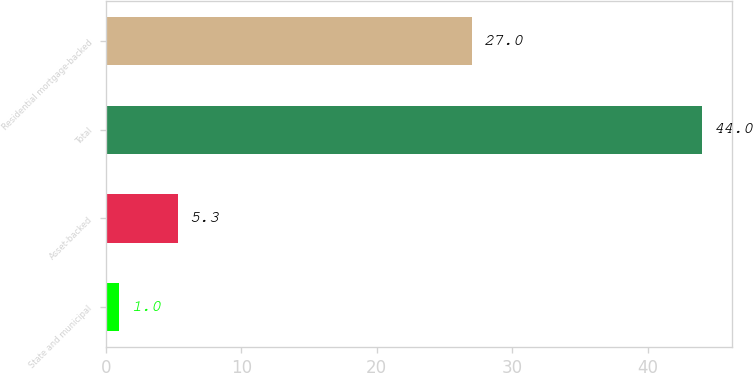Convert chart to OTSL. <chart><loc_0><loc_0><loc_500><loc_500><bar_chart><fcel>State and municipal<fcel>Asset-backed<fcel>Total<fcel>Residential mortgage-backed<nl><fcel>1<fcel>5.3<fcel>44<fcel>27<nl></chart> 